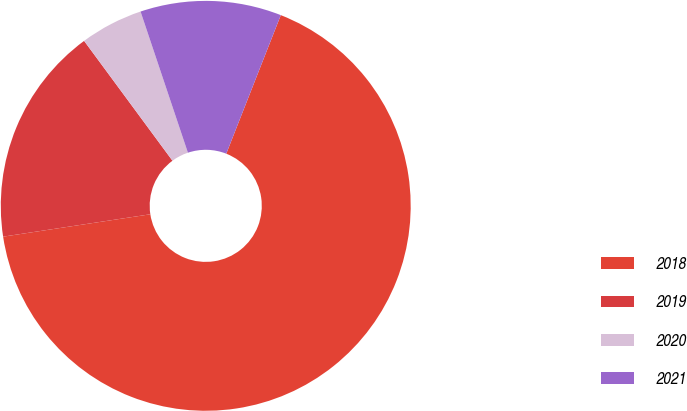Convert chart to OTSL. <chart><loc_0><loc_0><loc_500><loc_500><pie_chart><fcel>2018<fcel>2019<fcel>2020<fcel>2021<nl><fcel>66.63%<fcel>17.29%<fcel>4.96%<fcel>11.12%<nl></chart> 